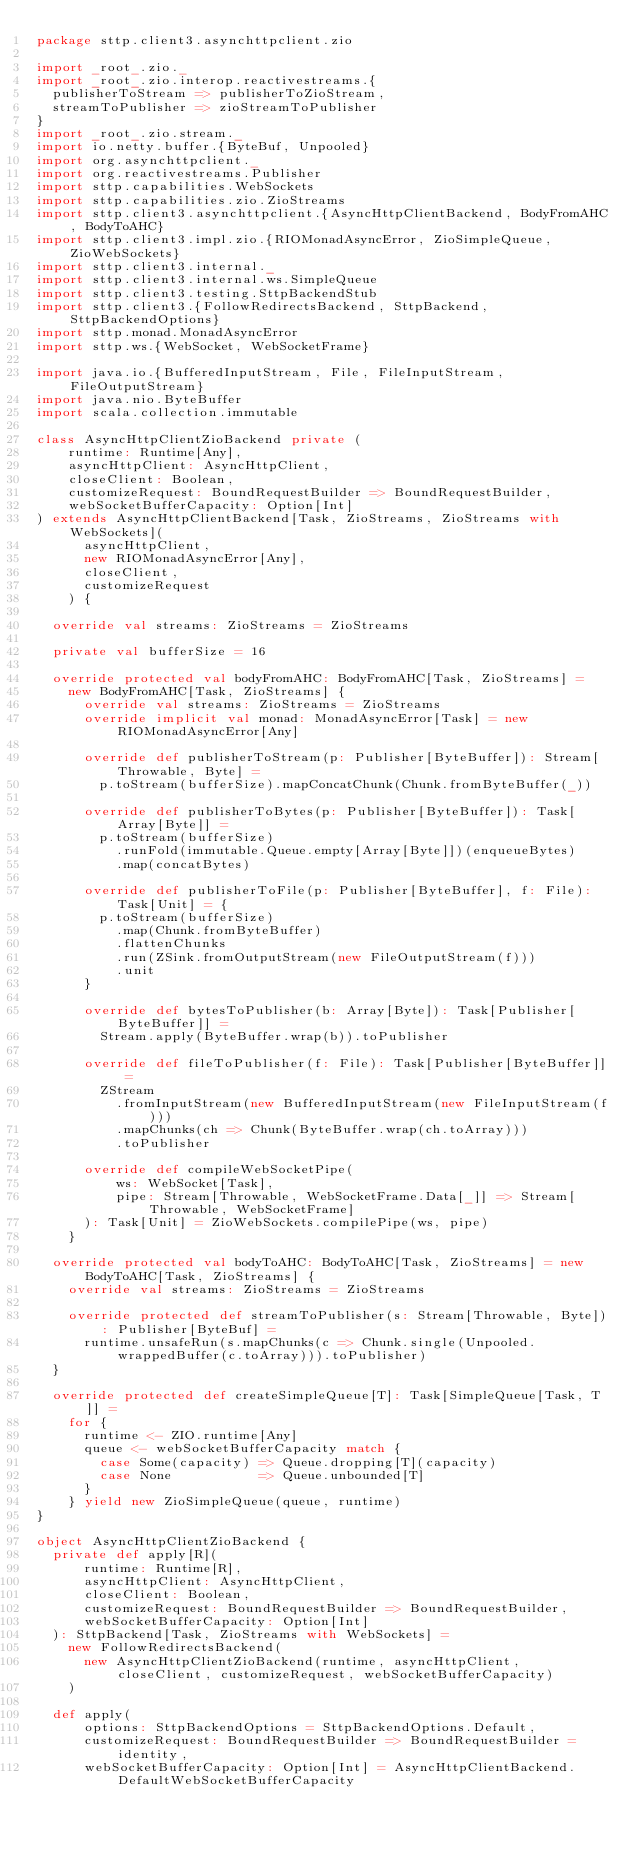Convert code to text. <code><loc_0><loc_0><loc_500><loc_500><_Scala_>package sttp.client3.asynchttpclient.zio

import _root_.zio._
import _root_.zio.interop.reactivestreams.{
  publisherToStream => publisherToZioStream,
  streamToPublisher => zioStreamToPublisher
}
import _root_.zio.stream._
import io.netty.buffer.{ByteBuf, Unpooled}
import org.asynchttpclient._
import org.reactivestreams.Publisher
import sttp.capabilities.WebSockets
import sttp.capabilities.zio.ZioStreams
import sttp.client3.asynchttpclient.{AsyncHttpClientBackend, BodyFromAHC, BodyToAHC}
import sttp.client3.impl.zio.{RIOMonadAsyncError, ZioSimpleQueue, ZioWebSockets}
import sttp.client3.internal._
import sttp.client3.internal.ws.SimpleQueue
import sttp.client3.testing.SttpBackendStub
import sttp.client3.{FollowRedirectsBackend, SttpBackend, SttpBackendOptions}
import sttp.monad.MonadAsyncError
import sttp.ws.{WebSocket, WebSocketFrame}

import java.io.{BufferedInputStream, File, FileInputStream, FileOutputStream}
import java.nio.ByteBuffer
import scala.collection.immutable

class AsyncHttpClientZioBackend private (
    runtime: Runtime[Any],
    asyncHttpClient: AsyncHttpClient,
    closeClient: Boolean,
    customizeRequest: BoundRequestBuilder => BoundRequestBuilder,
    webSocketBufferCapacity: Option[Int]
) extends AsyncHttpClientBackend[Task, ZioStreams, ZioStreams with WebSockets](
      asyncHttpClient,
      new RIOMonadAsyncError[Any],
      closeClient,
      customizeRequest
    ) {

  override val streams: ZioStreams = ZioStreams

  private val bufferSize = 16

  override protected val bodyFromAHC: BodyFromAHC[Task, ZioStreams] =
    new BodyFromAHC[Task, ZioStreams] {
      override val streams: ZioStreams = ZioStreams
      override implicit val monad: MonadAsyncError[Task] = new RIOMonadAsyncError[Any]

      override def publisherToStream(p: Publisher[ByteBuffer]): Stream[Throwable, Byte] =
        p.toStream(bufferSize).mapConcatChunk(Chunk.fromByteBuffer(_))

      override def publisherToBytes(p: Publisher[ByteBuffer]): Task[Array[Byte]] =
        p.toStream(bufferSize)
          .runFold(immutable.Queue.empty[Array[Byte]])(enqueueBytes)
          .map(concatBytes)

      override def publisherToFile(p: Publisher[ByteBuffer], f: File): Task[Unit] = {
        p.toStream(bufferSize)
          .map(Chunk.fromByteBuffer)
          .flattenChunks
          .run(ZSink.fromOutputStream(new FileOutputStream(f)))
          .unit
      }

      override def bytesToPublisher(b: Array[Byte]): Task[Publisher[ByteBuffer]] =
        Stream.apply(ByteBuffer.wrap(b)).toPublisher

      override def fileToPublisher(f: File): Task[Publisher[ByteBuffer]] =
        ZStream
          .fromInputStream(new BufferedInputStream(new FileInputStream(f)))
          .mapChunks(ch => Chunk(ByteBuffer.wrap(ch.toArray)))
          .toPublisher

      override def compileWebSocketPipe(
          ws: WebSocket[Task],
          pipe: Stream[Throwable, WebSocketFrame.Data[_]] => Stream[Throwable, WebSocketFrame]
      ): Task[Unit] = ZioWebSockets.compilePipe(ws, pipe)
    }

  override protected val bodyToAHC: BodyToAHC[Task, ZioStreams] = new BodyToAHC[Task, ZioStreams] {
    override val streams: ZioStreams = ZioStreams

    override protected def streamToPublisher(s: Stream[Throwable, Byte]): Publisher[ByteBuf] =
      runtime.unsafeRun(s.mapChunks(c => Chunk.single(Unpooled.wrappedBuffer(c.toArray))).toPublisher)
  }

  override protected def createSimpleQueue[T]: Task[SimpleQueue[Task, T]] =
    for {
      runtime <- ZIO.runtime[Any]
      queue <- webSocketBufferCapacity match {
        case Some(capacity) => Queue.dropping[T](capacity)
        case None           => Queue.unbounded[T]
      }
    } yield new ZioSimpleQueue(queue, runtime)
}

object AsyncHttpClientZioBackend {
  private def apply[R](
      runtime: Runtime[R],
      asyncHttpClient: AsyncHttpClient,
      closeClient: Boolean,
      customizeRequest: BoundRequestBuilder => BoundRequestBuilder,
      webSocketBufferCapacity: Option[Int]
  ): SttpBackend[Task, ZioStreams with WebSockets] =
    new FollowRedirectsBackend(
      new AsyncHttpClientZioBackend(runtime, asyncHttpClient, closeClient, customizeRequest, webSocketBufferCapacity)
    )

  def apply(
      options: SttpBackendOptions = SttpBackendOptions.Default,
      customizeRequest: BoundRequestBuilder => BoundRequestBuilder = identity,
      webSocketBufferCapacity: Option[Int] = AsyncHttpClientBackend.DefaultWebSocketBufferCapacity</code> 